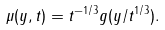Convert formula to latex. <formula><loc_0><loc_0><loc_500><loc_500>\mu ( y , t ) = t ^ { - 1 / 3 } g ( y / t ^ { 1 / 3 } ) .</formula> 